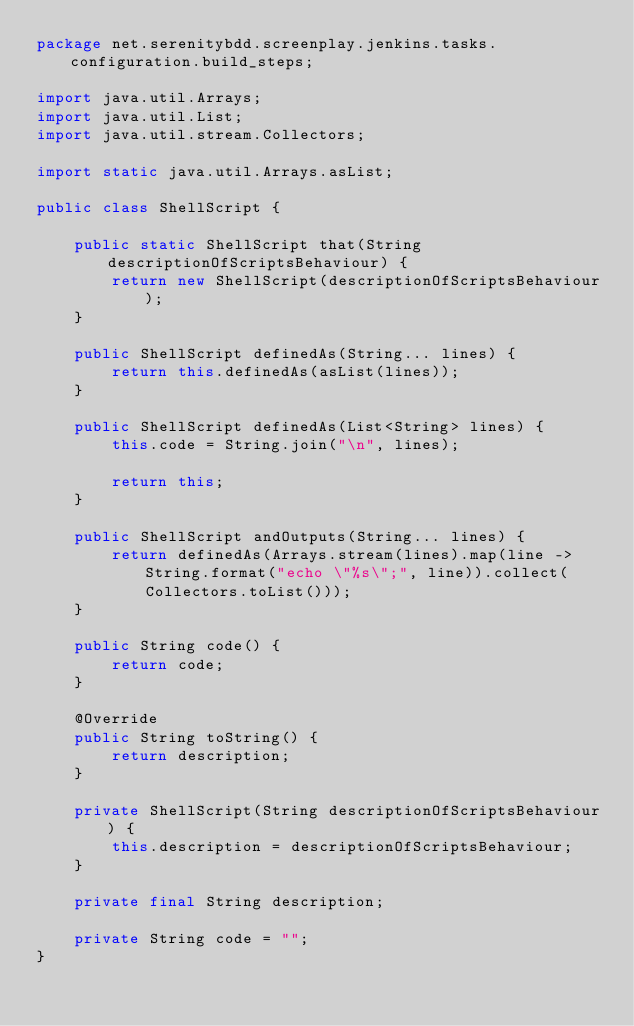<code> <loc_0><loc_0><loc_500><loc_500><_Java_>package net.serenitybdd.screenplay.jenkins.tasks.configuration.build_steps;

import java.util.Arrays;
import java.util.List;
import java.util.stream.Collectors;

import static java.util.Arrays.asList;

public class ShellScript {

    public static ShellScript that(String descriptionOfScriptsBehaviour) {
        return new ShellScript(descriptionOfScriptsBehaviour);
    }

    public ShellScript definedAs(String... lines) {
        return this.definedAs(asList(lines));
    }

    public ShellScript definedAs(List<String> lines) {
        this.code = String.join("\n", lines);

        return this;
    }

    public ShellScript andOutputs(String... lines) {
        return definedAs(Arrays.stream(lines).map(line -> String.format("echo \"%s\";", line)).collect(Collectors.toList()));
    }

    public String code() {
        return code;
    }

    @Override
    public String toString() {
        return description;
    }

    private ShellScript(String descriptionOfScriptsBehaviour) {
        this.description = descriptionOfScriptsBehaviour;
    }

    private final String description;

    private String code = "";
}
</code> 